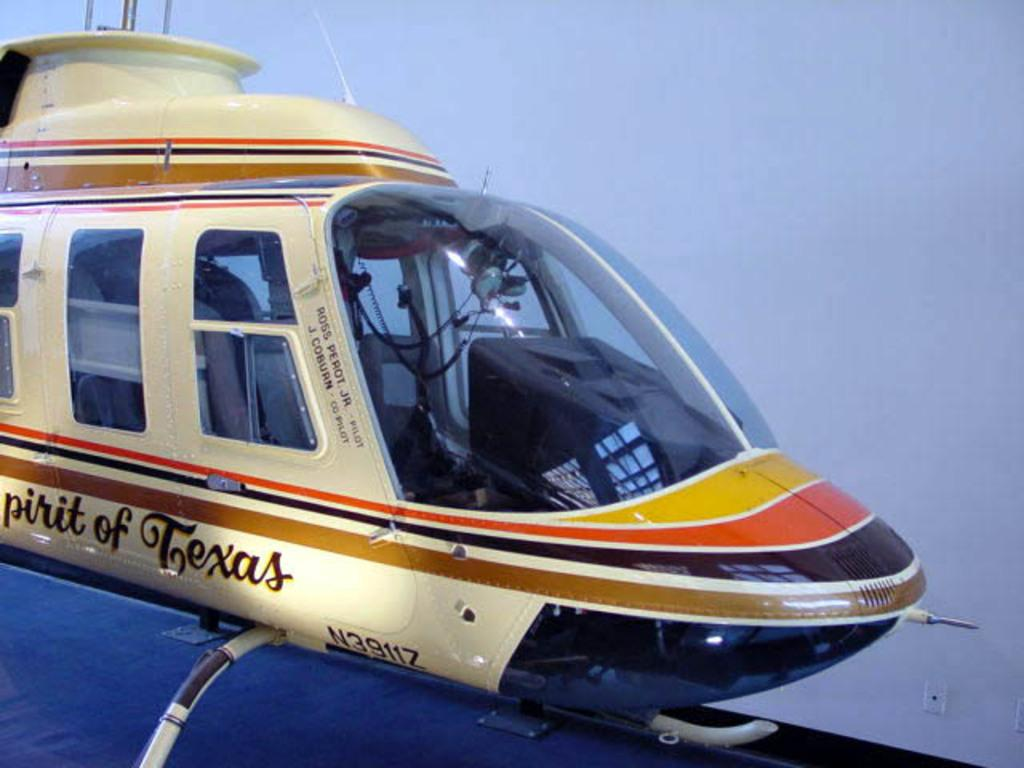What is the main subject of the image? The main subject of the image is an airplane. How is the airplane depicted in the image? The airplane appears to be truncated. What color is the background of the image? The background of the image is white. Can you see a kitten playing on the mountain in the image? There is no kitten or mountain present in the image; it features an airplane with a white background. 